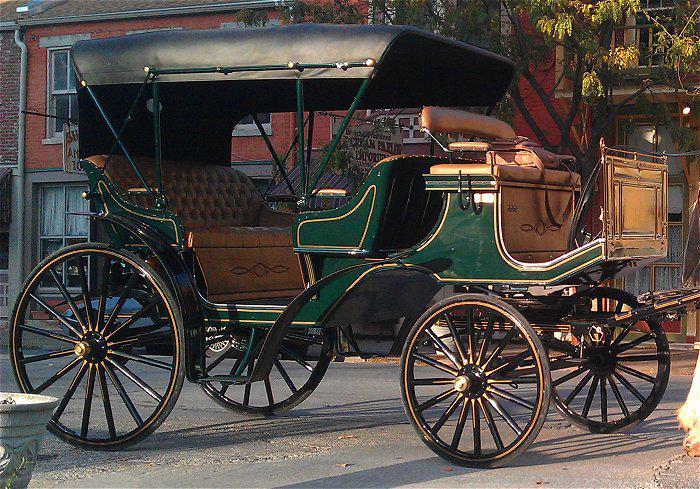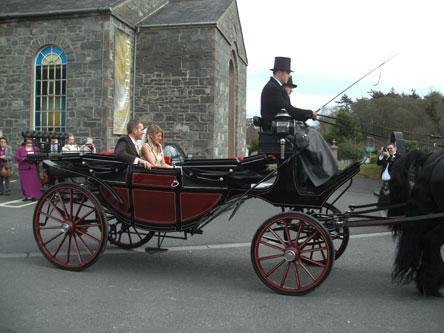The first image is the image on the left, the second image is the image on the right. Given the left and right images, does the statement "There is a total of two empty four wheel carts." hold true? Answer yes or no. No. The first image is the image on the left, the second image is the image on the right. For the images displayed, is the sentence "The carriage in the right image is covered." factually correct? Answer yes or no. No. 